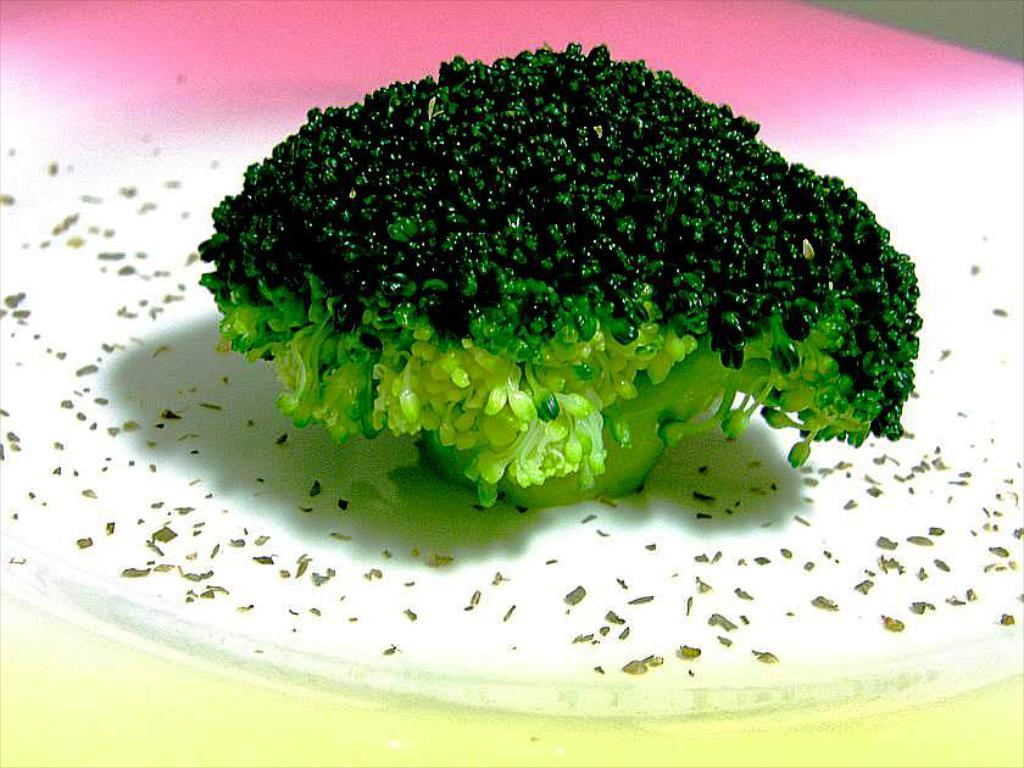What type of vegetable is present in the image? There is broccoli in the image. What color is the broccoli? The broccoli is green in color. What is the surface on which the broccoli is placed? The broccoli is on a white, pink, and yellow surface. Is there any blood visible on the broccoli in the image? No, there is no blood visible on the broccoli in the image. Can you see a ray of light shining on the broccoli in the image? There is no mention of a ray of light in the provided facts, so we cannot determine if it is present in the image. 